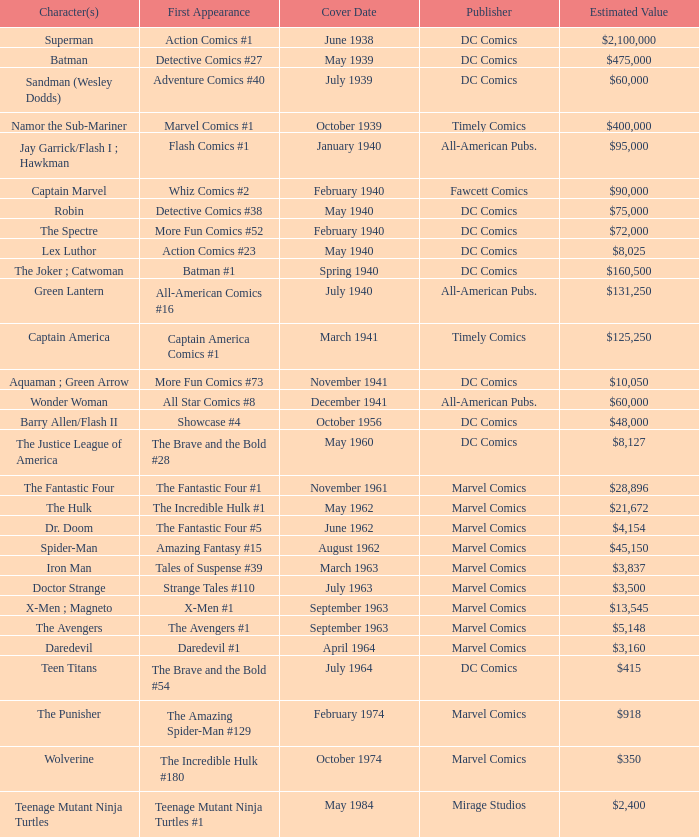Who produces wolverine? Marvel Comics. 